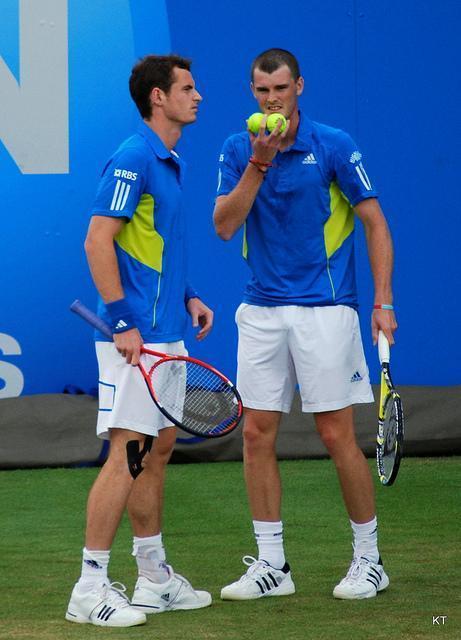How many balls is he holding?
Give a very brief answer. 2. How many people are there?
Give a very brief answer. 2. How many animals have a bird on their back?
Give a very brief answer. 0. 